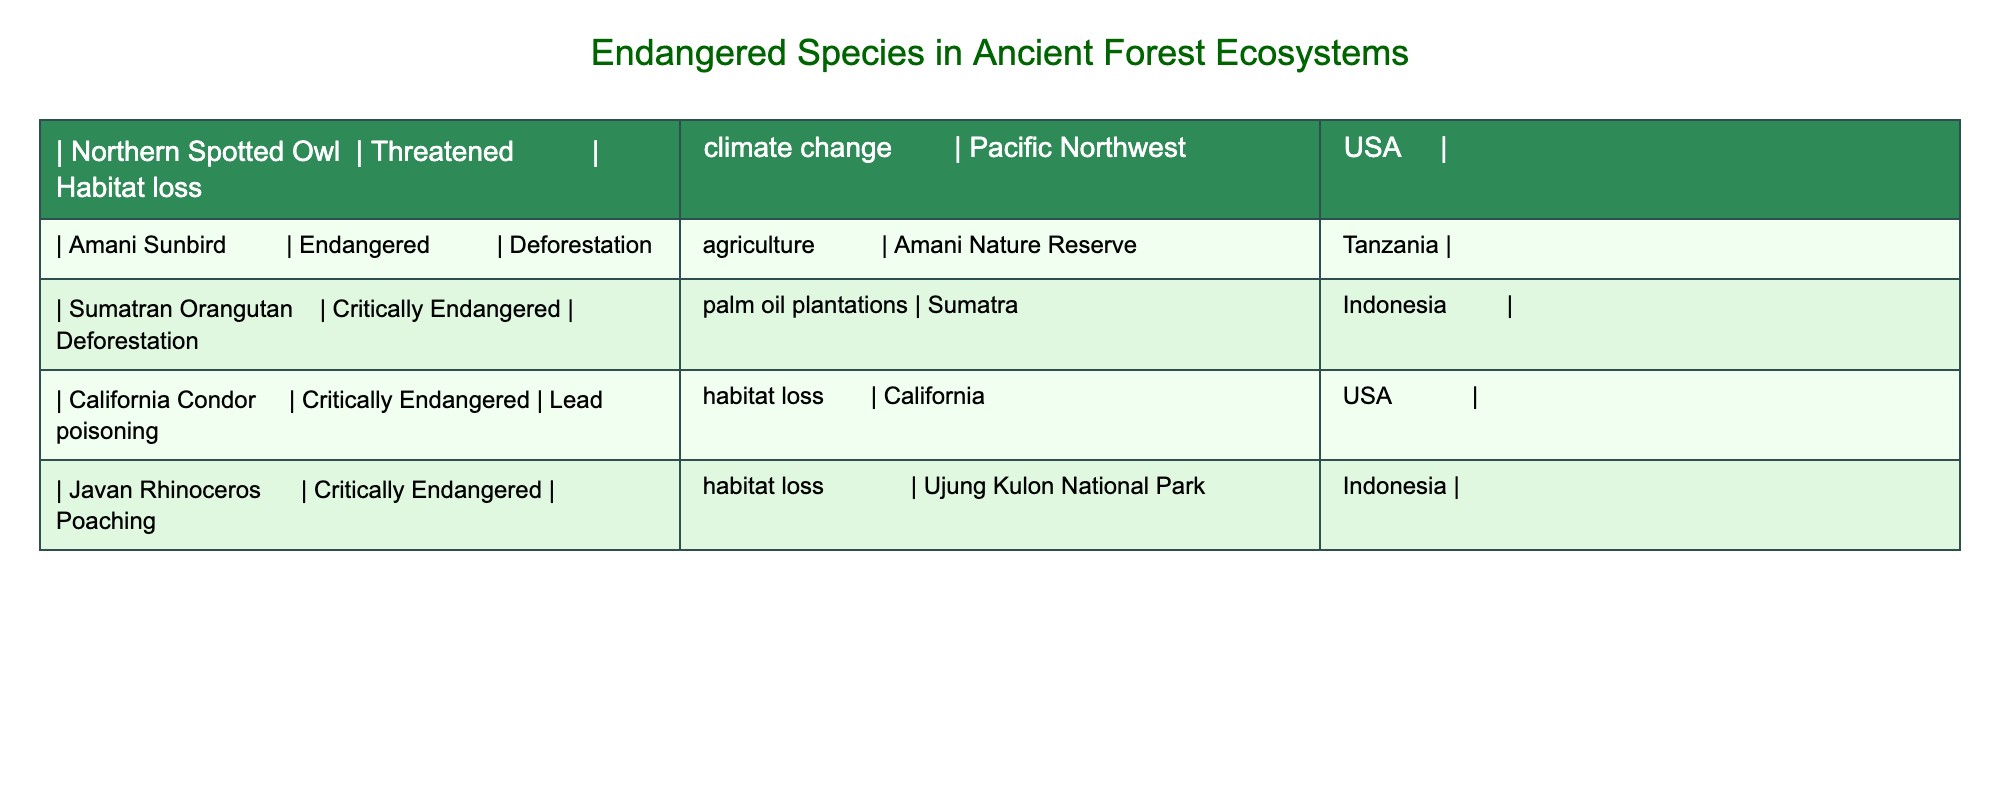What is the conservation status of the Northern Spotted Owl? The table lists the Northern Spotted Owl and denotes its conservation status as Threatened.
Answer: Threatened Which species face threats due to habitat loss? The table lists the species facing habitat loss as Northern Spotted Owl, California Condor, and Javan Rhinoceros.
Answer: Northern Spotted Owl, California Condor, Javan Rhinoceros How many species are Critically Endangered? The table specifically identifies three species as Critically Endangered: Sumatran Orangutan, California Condor, and Javan Rhinoceros. Therefore, the count is three.
Answer: Three Is the Amani Sunbird found in the USA? The Amani Sunbird is noted to be located in the Amani Nature Reserve in Tanzania, which indicates it is not found in the USA.
Answer: No Which species have threats related to deforestation? The table mentions that the Amani Sunbird and Sumatran Orangutan are both threatened by deforestation, indicating a common risk.
Answer: Amani Sunbird, Sumatran Orangutan What is the differing threat faced by the California Condor compared to the Northern Spotted Owl? The California Condor faces lead poisoning and habitat loss, while the Northern Spotted Owl primarily faces habitat loss and climate change, highlighting distinct threats.
Answer: Lead poisoning and habitat loss What percentage of the listed species is considered Endangered or Critically Endangered? There are a total of five species, of which two are Endangered and three are Critically Endangered. This totals five species classified as Endangered or Critically Endangered, resulting in 100%.
Answer: 100% Which species occurs in Sumatra, Indonesia? The specific mention of species in the table clarifies that the Sumatran Orangutan resides in Sumatra, Indonesia.
Answer: Sumatran Orangutan Which species suffers from poaching threats? The table reveals that the Javan Rhinoceros suffers from poaching, which marks it as one of the prominent threats listed.
Answer: Javan Rhinoceros 